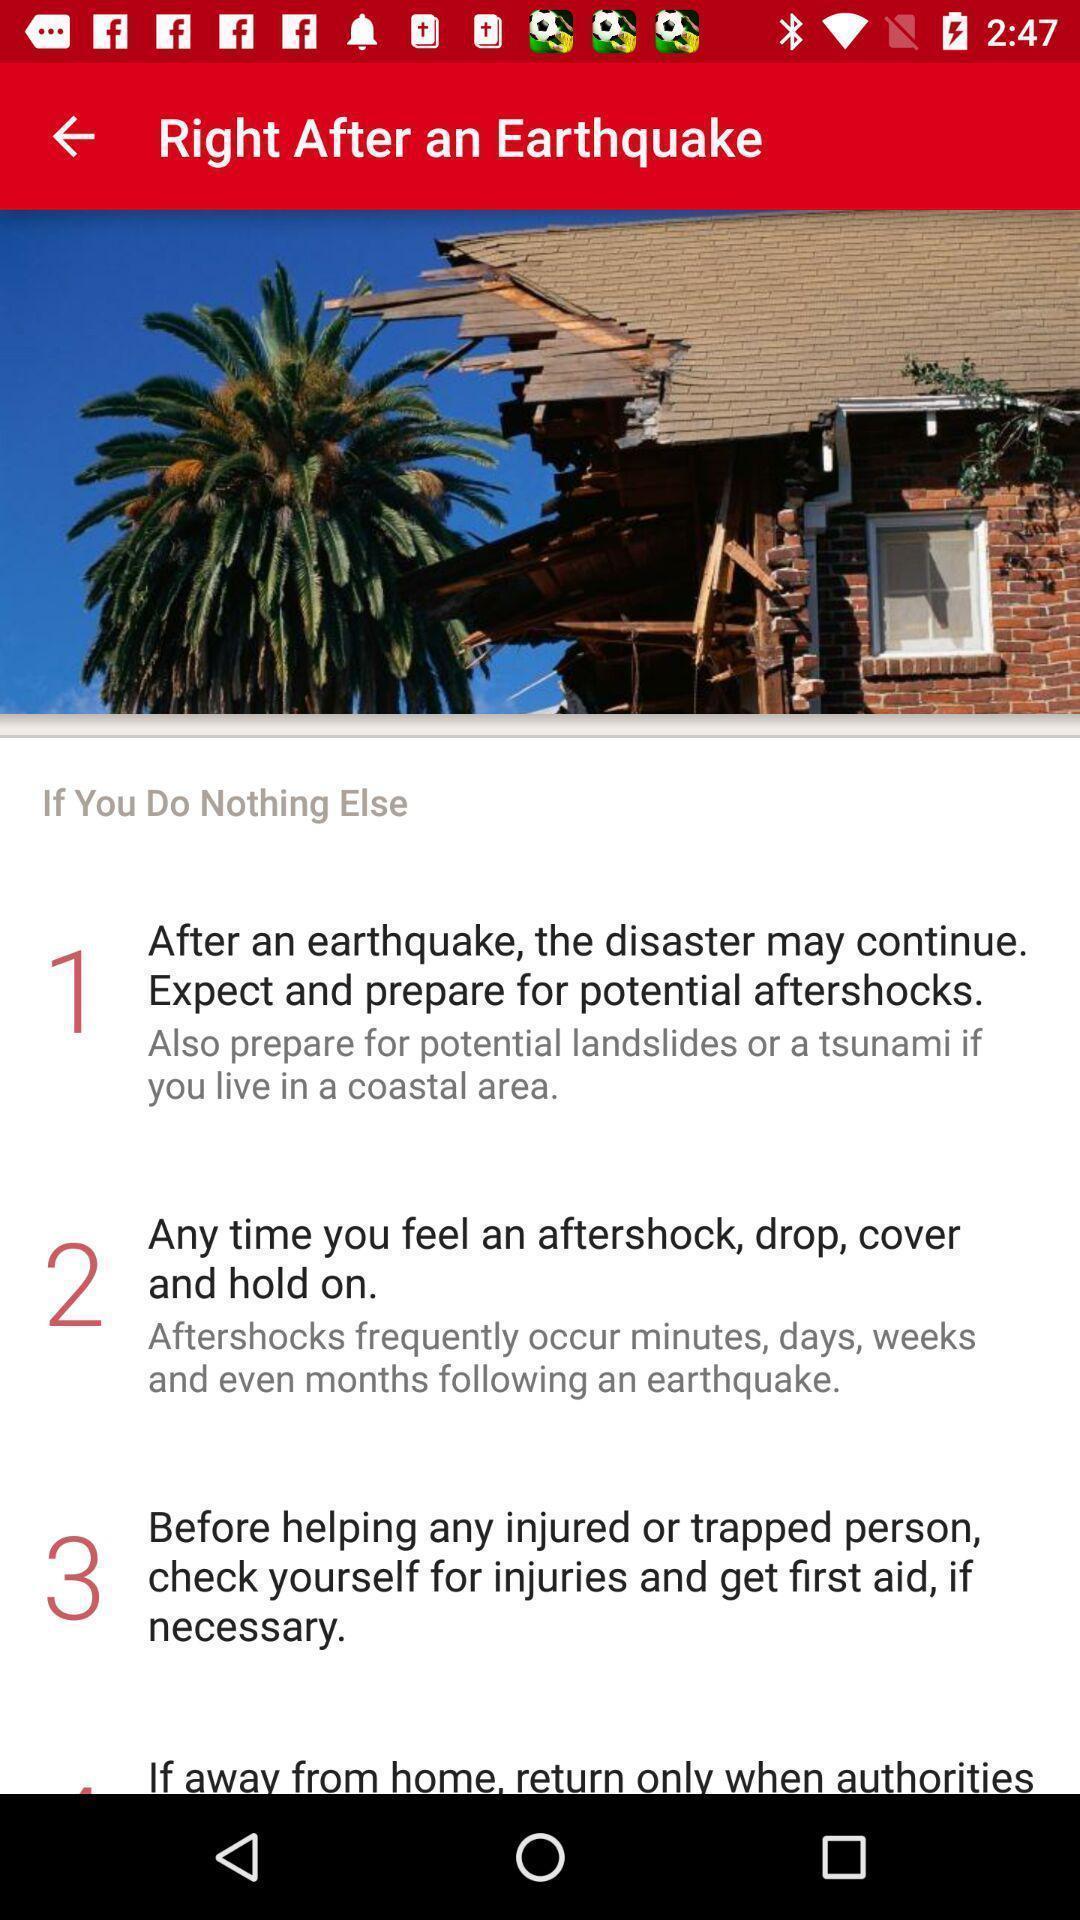Please provide a description for this image. Screen shows information about an earthquake. 